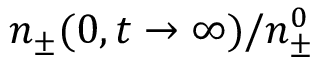Convert formula to latex. <formula><loc_0><loc_0><loc_500><loc_500>n _ { \pm } ( 0 , t \to \infty ) / n _ { \pm } ^ { 0 }</formula> 